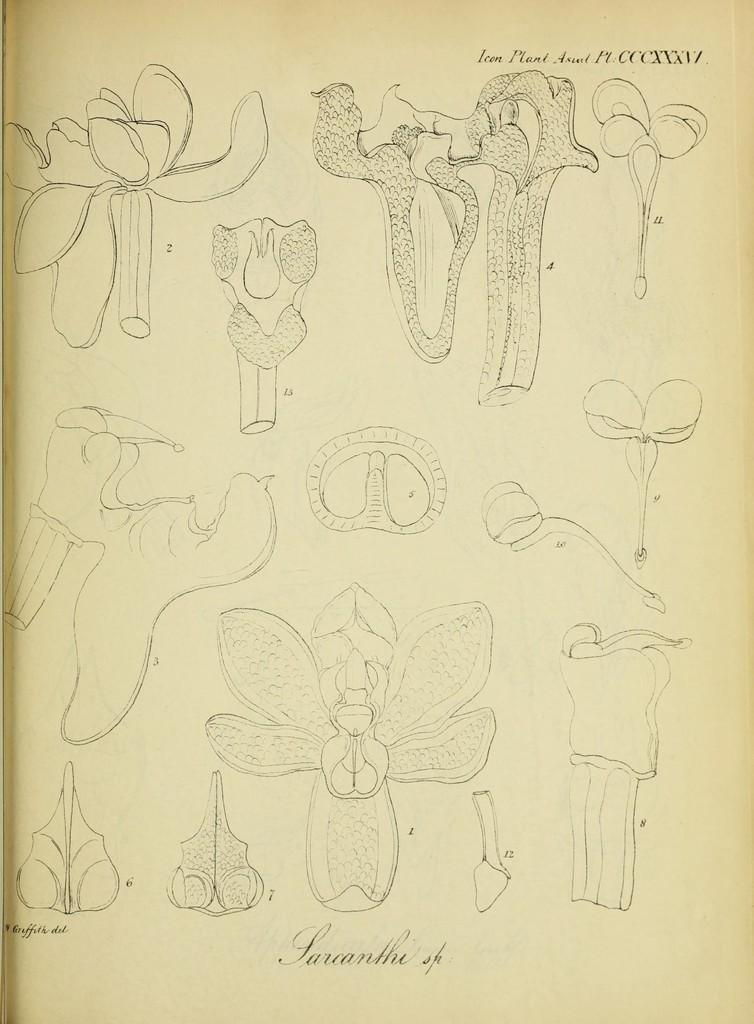What is depicted in the image? The image contains a sketch of a part of a plant. What is the color of the paper on which the sketch is drawn? The sketch is on cream-colored paper. What type of magic can be seen in the image? There is no magic present in the image; it contains a sketch of a part of a plant on cream-colored paper. 